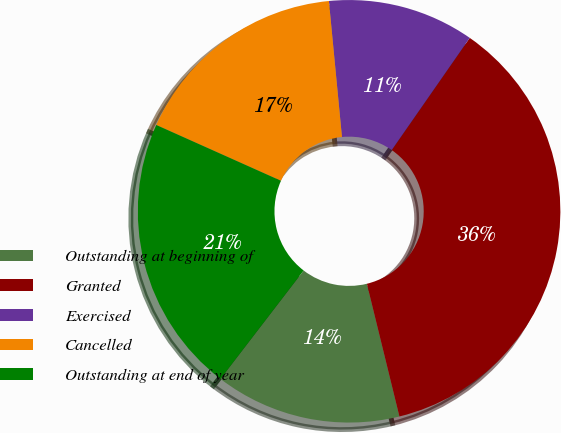<chart> <loc_0><loc_0><loc_500><loc_500><pie_chart><fcel>Outstanding at beginning of<fcel>Granted<fcel>Exercised<fcel>Cancelled<fcel>Outstanding at end of year<nl><fcel>14.25%<fcel>36.5%<fcel>11.2%<fcel>16.78%<fcel>21.28%<nl></chart> 